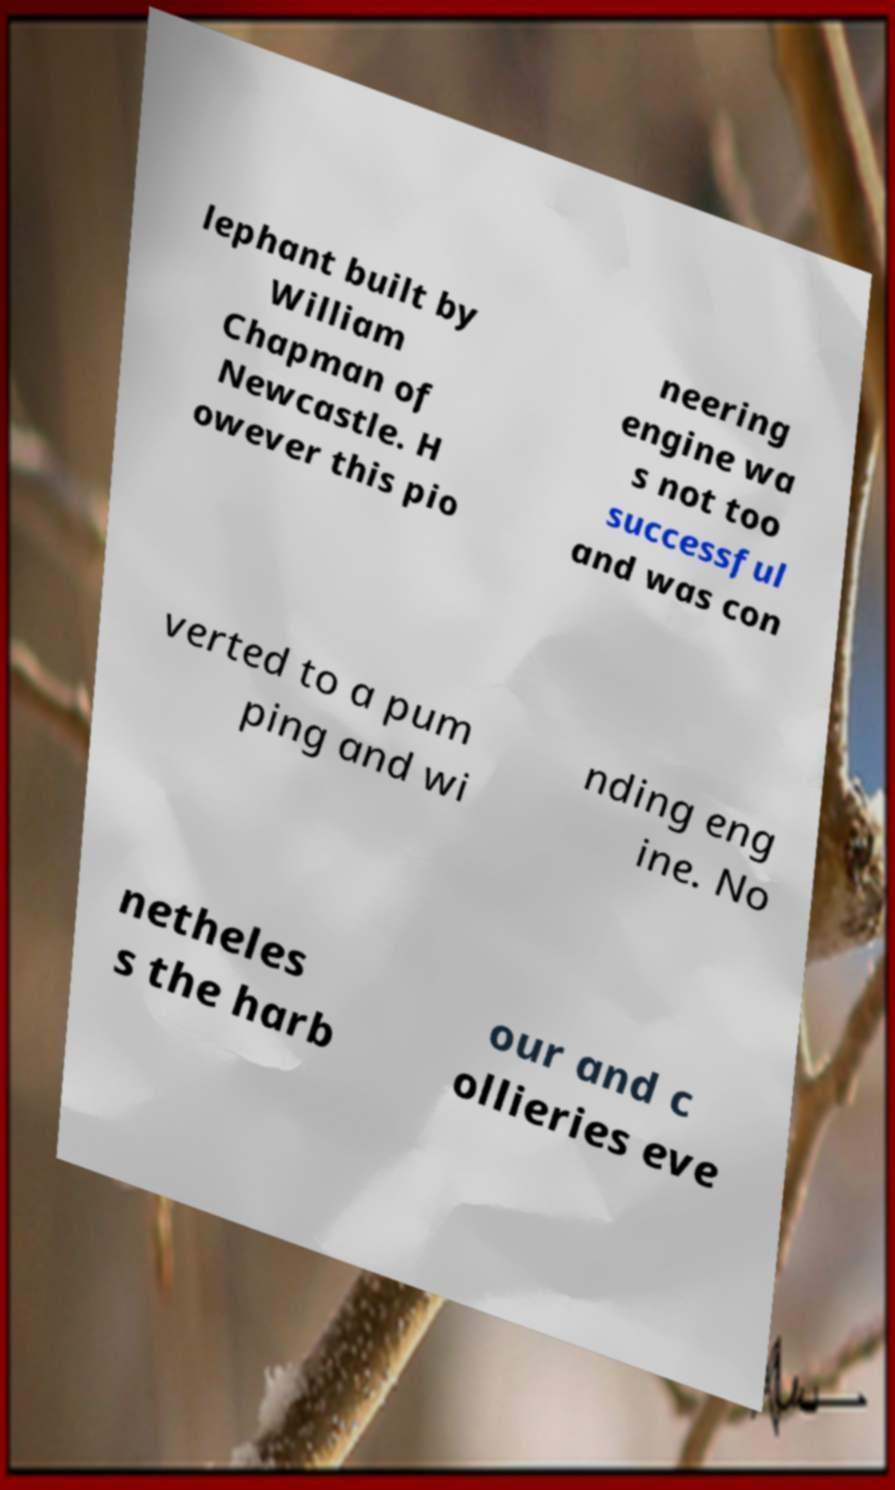Please identify and transcribe the text found in this image. lephant built by William Chapman of Newcastle. H owever this pio neering engine wa s not too successful and was con verted to a pum ping and wi nding eng ine. No netheles s the harb our and c ollieries eve 